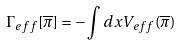<formula> <loc_0><loc_0><loc_500><loc_500>\Gamma _ { e f f } [ \overline { \pi } ] = - \int d x V _ { e f f } ( \overline { \pi } )</formula> 